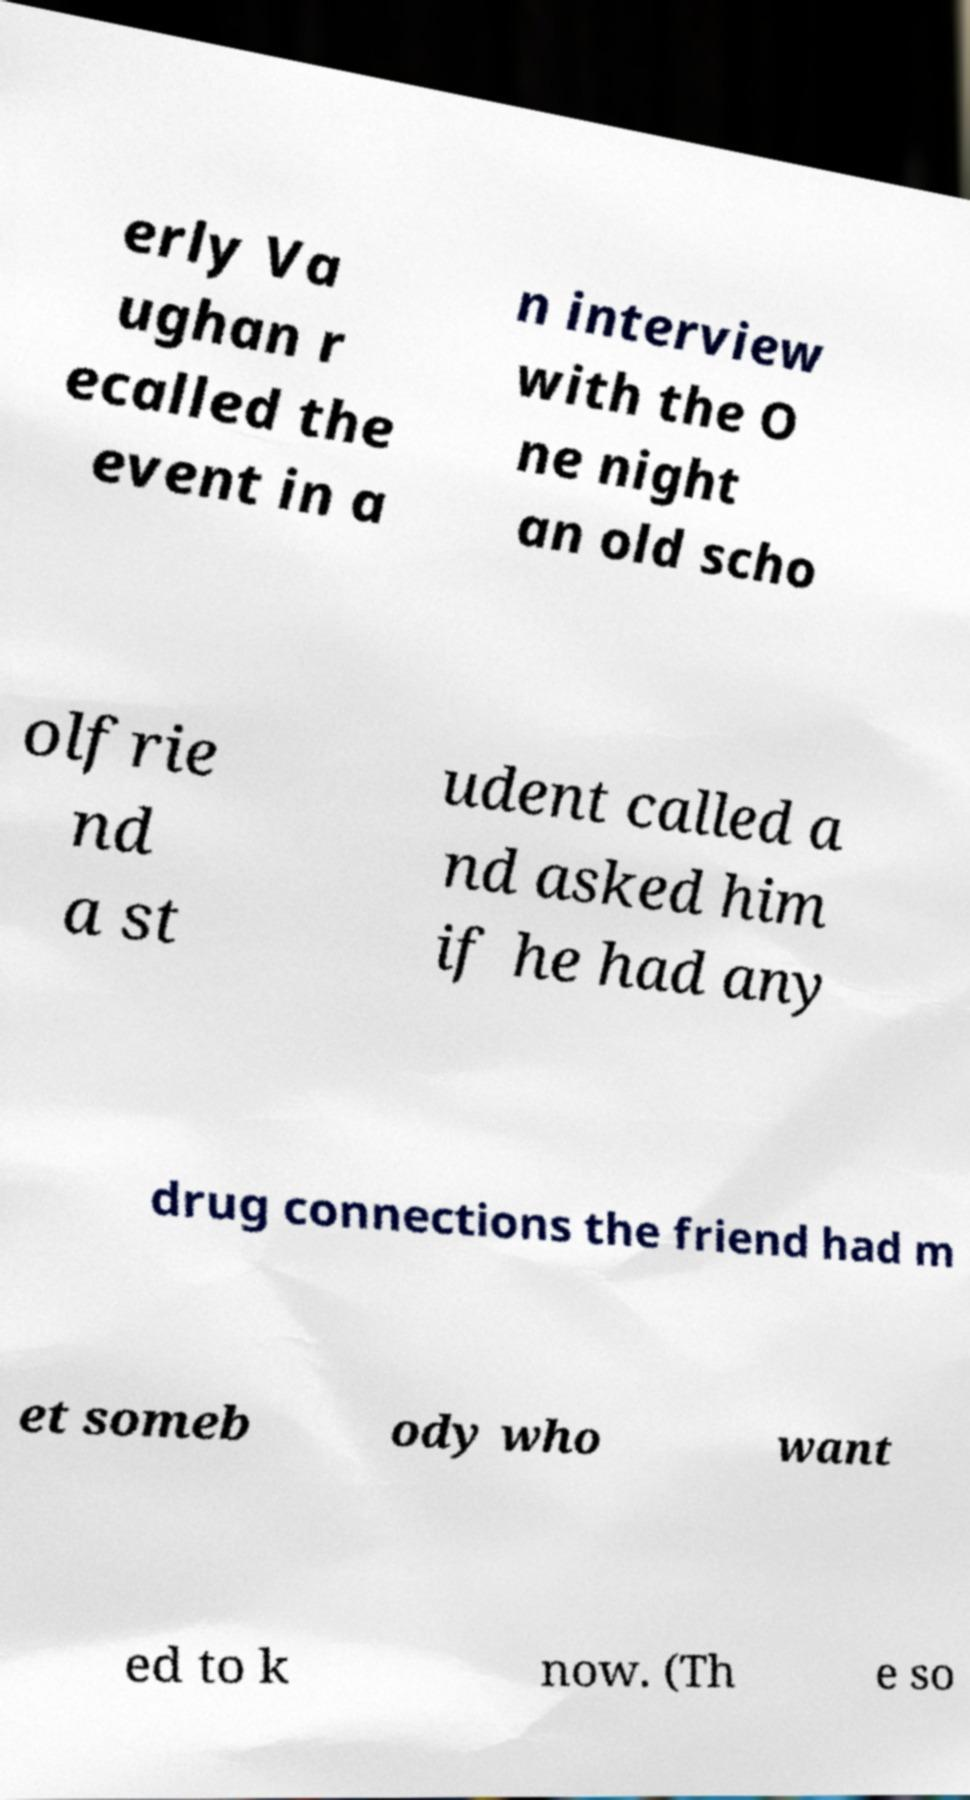Can you read and provide the text displayed in the image?This photo seems to have some interesting text. Can you extract and type it out for me? erly Va ughan r ecalled the event in a n interview with the O ne night an old scho olfrie nd a st udent called a nd asked him if he had any drug connections the friend had m et someb ody who want ed to k now. (Th e so 